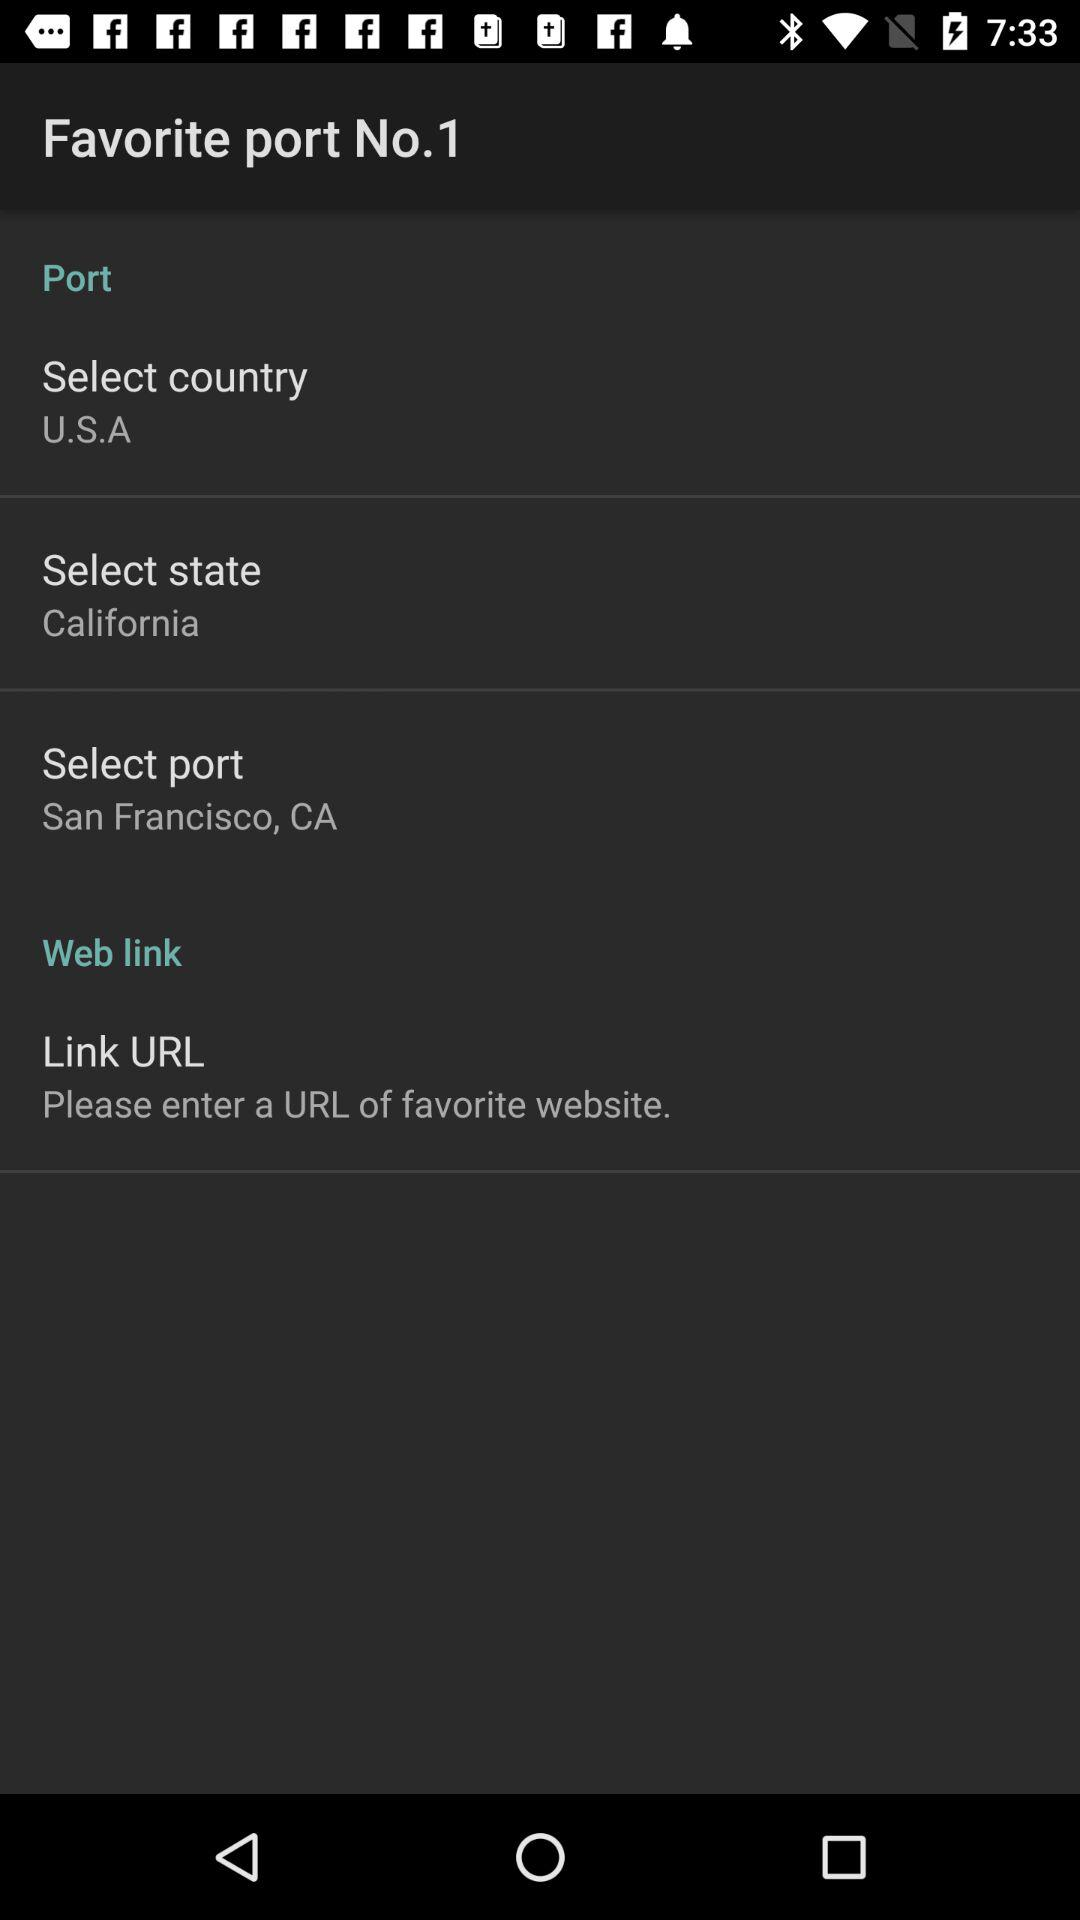What port is selected? The selected port is San Francisco, CA. 